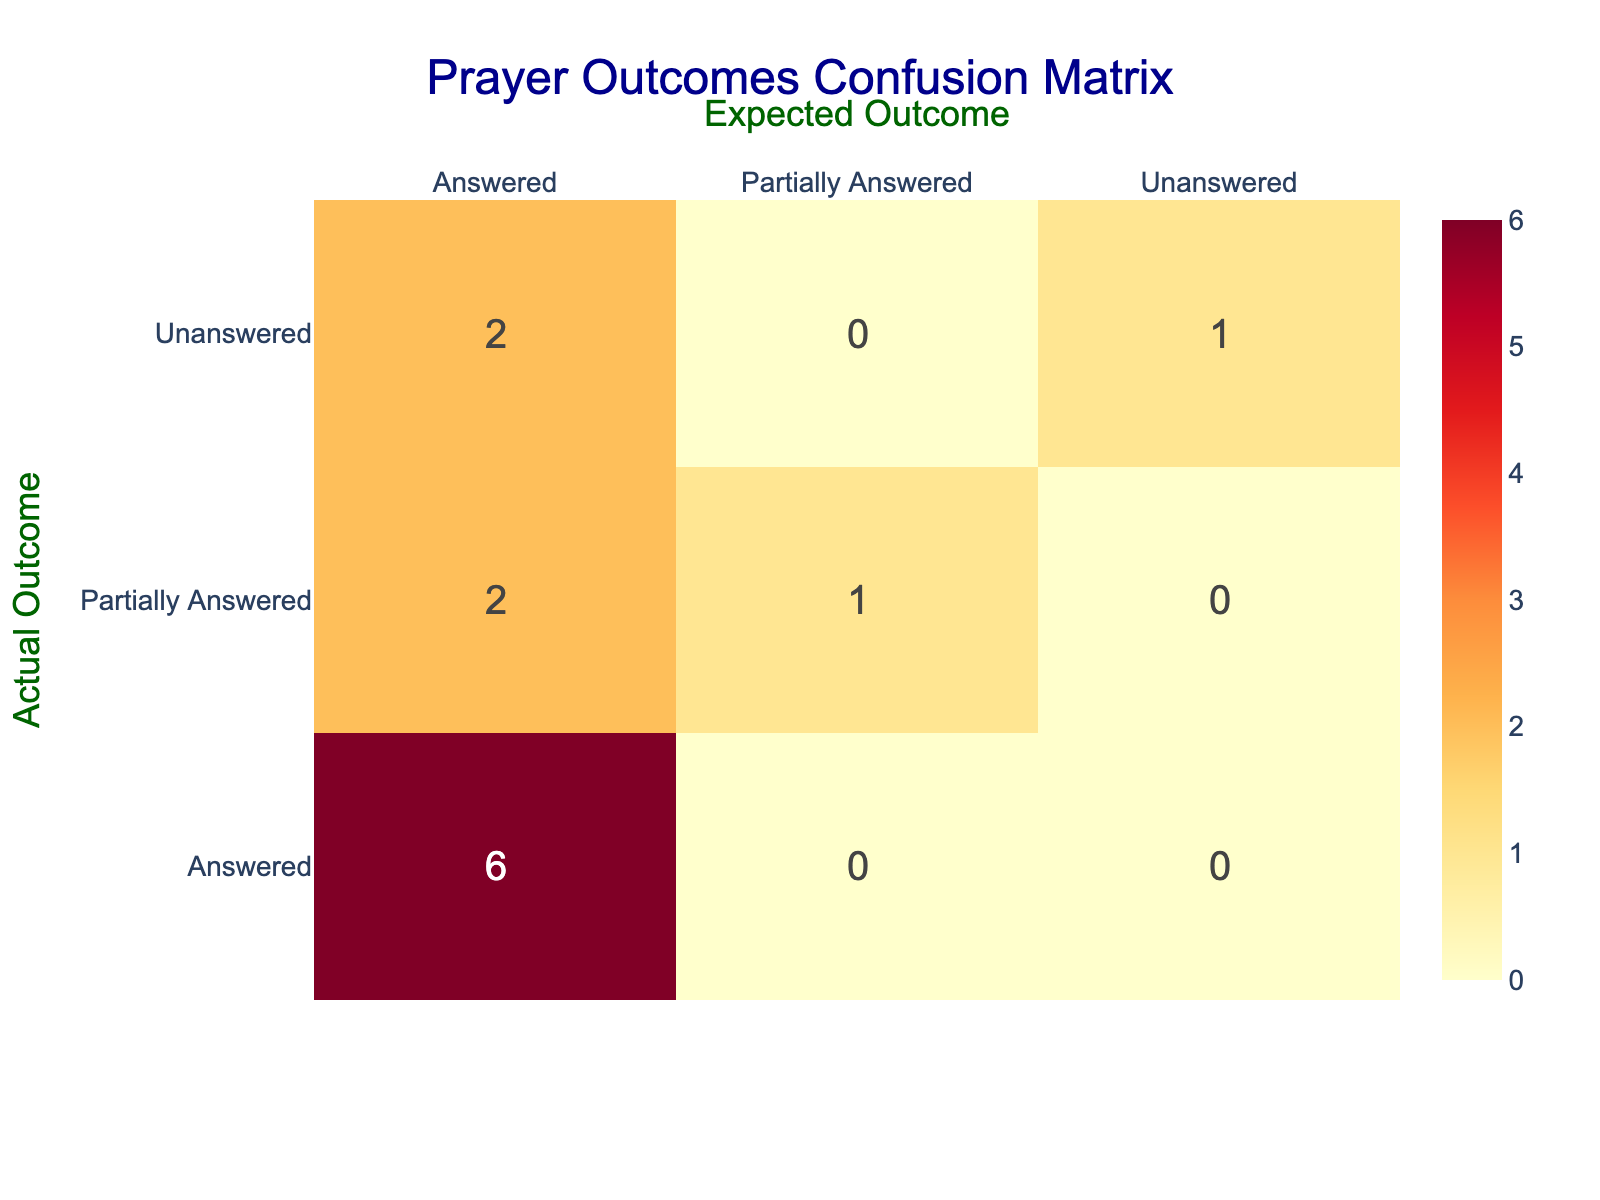What is the total number of prayer sessions that were fully answered? By looking at the "Prayer Outcome" row labeled as "Answered," we can see that this outcome occurred in sessions 1, 3, 6, 8, 10, and 12. There are 6 sessions that resulted in a fully answered prayer.
Answer: 6 How many prayer sessions were expected to be unanswered but were actually answered? We can find the row where "Expected Outcome" is "Unanswered" and then check how many of these have "Prayer Outcome" as "Answered." Looking at the relevant session entries, we find that session 9 is the only one fitting this criteria.
Answer: 1 What is the total count of partially answered prayer sessions? From the "Prayer Outcome" categories, "Partially Answered" appears in sessions 4, 7, and 11. Counting these gives us a total of 3 partially answered sessions.
Answer: 3 Did any prayer sessions related to healing actually go unanswered? Checking the row for the theological concept of "Healing," we see that the outcome was "Answered." Therefore, no sessions related to healing were left unanswered.
Answer: No What is the ratio of answered prayer sessions to unanswered prayer sessions? From the totals, we have 6 answered sessions and 3 unanswered ones. The ratio is calculated as 6 (answered) : 3 (unanswered) which simplifies to 2:1.
Answer: 2:1 How many theological concepts had both answered and partially answered outcomes? By examining the theological concepts that have occurrences of both "Answered" and "Partially Answered" outcomes, we find "Forgiveness" (Answered: 1, Partially Answered: 1) and "Redemption" (Expected: Answered, Outcome: Partially Answered). So there are 2 concepts: "Forgiveness" and "Redemption".
Answer: 2 What percentage of prayer sessions resulted in unanswered outcomes? To find this percentage, we first count the total number of prayer sessions (12 in total) and the number of unanswered outcomes (3). The percentage is calculated as (3 / 12) * 100 = 25%.
Answer: 25% Which theological concept had an expected outcome that was not met at all? By checking the "Expected Outcome" against the "Prayer Outcome," we find that "Suffering" had both its expected and actual outcomes as "Unanswered." No other theological concept had an unmet expectation thus.
Answer: Suffering 